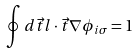Convert formula to latex. <formula><loc_0><loc_0><loc_500><loc_500>\oint d \vec { t } l \cdot \vec { t } \nabla \phi _ { i \sigma } = 1</formula> 